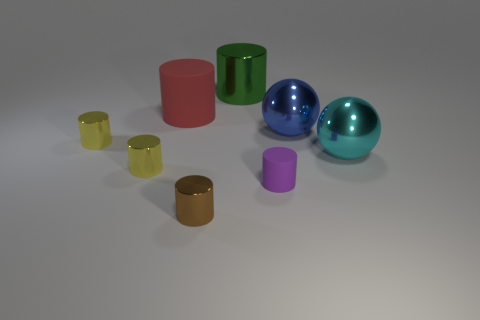Are the purple thing and the large red thing made of the same material?
Provide a succinct answer. Yes. Are there an equal number of large red objects to the right of the tiny purple thing and green shiny cylinders?
Your answer should be compact. No. How many big objects are made of the same material as the big cyan sphere?
Offer a very short reply. 2. Are there fewer small yellow shiny cylinders than cylinders?
Your response must be concise. Yes. There is a rubber object that is on the right side of the brown metal thing; does it have the same color as the large rubber cylinder?
Your answer should be very brief. No. There is a tiny metallic cylinder in front of the small object that is right of the brown object; what number of red rubber things are in front of it?
Offer a terse response. 0. What number of small yellow objects are in front of the large cyan shiny object?
Your response must be concise. 1. What is the color of the other large matte thing that is the same shape as the green thing?
Ensure brevity in your answer.  Red. There is a big object that is both on the left side of the tiny purple cylinder and to the right of the brown metallic cylinder; what material is it?
Provide a succinct answer. Metal. Is the size of the matte cylinder that is to the left of the green shiny cylinder the same as the purple cylinder?
Keep it short and to the point. No. 